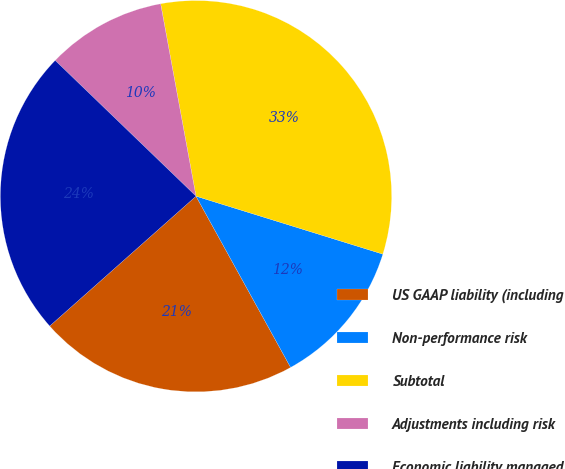Convert chart to OTSL. <chart><loc_0><loc_0><loc_500><loc_500><pie_chart><fcel>US GAAP liability (including<fcel>Non-performance risk<fcel>Subtotal<fcel>Adjustments including risk<fcel>Economic liability managed<nl><fcel>21.48%<fcel>12.18%<fcel>32.68%<fcel>9.9%<fcel>23.76%<nl></chart> 